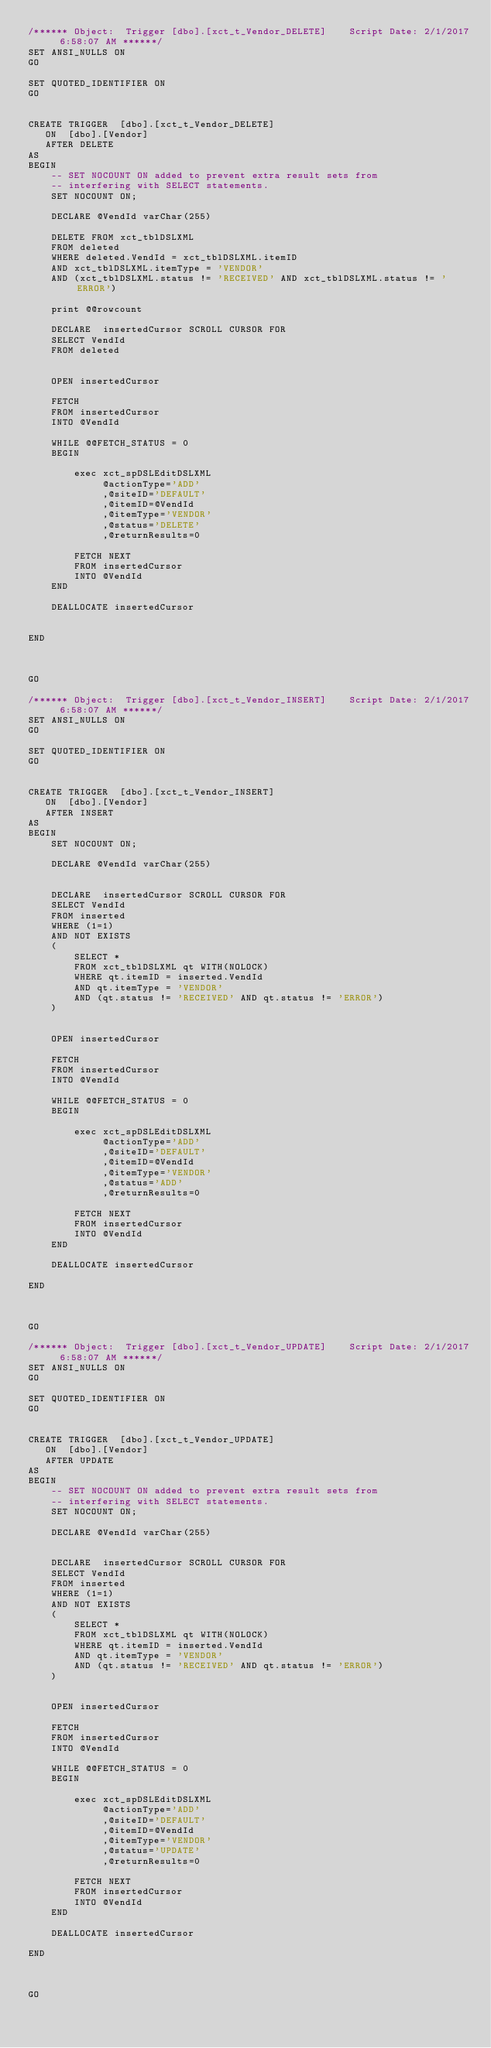Convert code to text. <code><loc_0><loc_0><loc_500><loc_500><_SQL_>/****** Object:  Trigger [dbo].[xct_t_Vendor_DELETE]    Script Date: 2/1/2017 6:58:07 AM ******/
SET ANSI_NULLS ON
GO

SET QUOTED_IDENTIFIER ON
GO


CREATE TRIGGER  [dbo].[xct_t_Vendor_DELETE]
   ON  [dbo].[Vendor]
   AFTER DELETE
AS 
BEGIN
	-- SET NOCOUNT ON added to prevent extra result sets from
	-- interfering with SELECT statements.
	SET NOCOUNT ON;

	DECLARE @VendId varChar(255)

	DELETE FROM xct_tblDSLXML
	FROM deleted
	WHERE deleted.VendId = xct_tblDSLXML.itemID
	AND xct_tblDSLXML.itemType = 'VENDOR'
	AND (xct_tblDSLXML.status != 'RECEIVED' AND xct_tblDSLXML.status != 'ERROR')

	print @@rowcount
	
	DECLARE  insertedCursor SCROLL CURSOR FOR
	SELECT VendId
	FROM deleted


	OPEN insertedCursor
	
	FETCH
	FROM insertedCursor
	INTO @VendId

	WHILE @@FETCH_STATUS = 0
	BEGIN

		exec xct_spDSLEditDSLXML   
			 @actionType='ADD'
			 ,@siteID='DEFAULT'
			 ,@itemID=@VendId
			 ,@itemType='VENDOR'
			 ,@status='DELETE'
			 ,@returnResults=0
			
		FETCH NEXT
		FROM insertedCursor
		INTO @VendId
	END

	DEALLOCATE insertedCursor


END



GO

/****** Object:  Trigger [dbo].[xct_t_Vendor_INSERT]    Script Date: 2/1/2017 6:58:07 AM ******/
SET ANSI_NULLS ON
GO

SET QUOTED_IDENTIFIER ON
GO


CREATE TRIGGER  [dbo].[xct_t_Vendor_INSERT]
   ON  [dbo].[Vendor]
   AFTER INSERT
AS 
BEGIN
	SET NOCOUNT ON;

	DECLARE @VendId varChar(255)
	
	
	DECLARE  insertedCursor SCROLL CURSOR FOR
	SELECT VendId
	FROM inserted
	WHERE (1=1)
	AND NOT EXISTS
	(
		SELECT *
		FROM xct_tblDSLXML qt WITH(NOLOCK)
		WHERE qt.itemID = inserted.VendId
		AND qt.itemType = 'VENDOR'
		AND (qt.status != 'RECEIVED' AND qt.status != 'ERROR')
	)


	OPEN insertedCursor
	
	FETCH
	FROM insertedCursor
	INTO @VendId

	WHILE @@FETCH_STATUS = 0
	BEGIN

		exec xct_spDSLEditDSLXML   
			 @actionType='ADD'
			 ,@siteID='DEFAULT'
			 ,@itemID=@VendId
			 ,@itemType='VENDOR'
			 ,@status='ADD'
			 ,@returnResults=0
			
		FETCH NEXT
		FROM insertedCursor
		INTO @VendId
	END

	DEALLOCATE insertedCursor

END



GO

/****** Object:  Trigger [dbo].[xct_t_Vendor_UPDATE]    Script Date: 2/1/2017 6:58:07 AM ******/
SET ANSI_NULLS ON
GO

SET QUOTED_IDENTIFIER ON
GO


CREATE TRIGGER  [dbo].[xct_t_Vendor_UPDATE]
   ON  [dbo].[Vendor]
   AFTER UPDATE
AS 
BEGIN
	-- SET NOCOUNT ON added to prevent extra result sets from
	-- interfering with SELECT statements.
	SET NOCOUNT ON;

	DECLARE @VendId varChar(255)
	
	
	DECLARE  insertedCursor SCROLL CURSOR FOR
	SELECT VendId
	FROM inserted
	WHERE (1=1)
	AND NOT EXISTS
	(
		SELECT *
		FROM xct_tblDSLXML qt WITH(NOLOCK)
		WHERE qt.itemID = inserted.VendId
		AND qt.itemType = 'VENDOR'
		AND (qt.status != 'RECEIVED' AND qt.status != 'ERROR')
	)


	OPEN insertedCursor
	
	FETCH
	FROM insertedCursor
	INTO @VendId

	WHILE @@FETCH_STATUS = 0
	BEGIN

		exec xct_spDSLEditDSLXML   
			 @actionType='ADD'
			 ,@siteID='DEFAULT'
			 ,@itemID=@VendId
			 ,@itemType='VENDOR'
			 ,@status='UPDATE'
			 ,@returnResults=0
			
		FETCH NEXT
		FROM insertedCursor
		INTO @VendId
	END

	DEALLOCATE insertedCursor

END



GO

</code> 